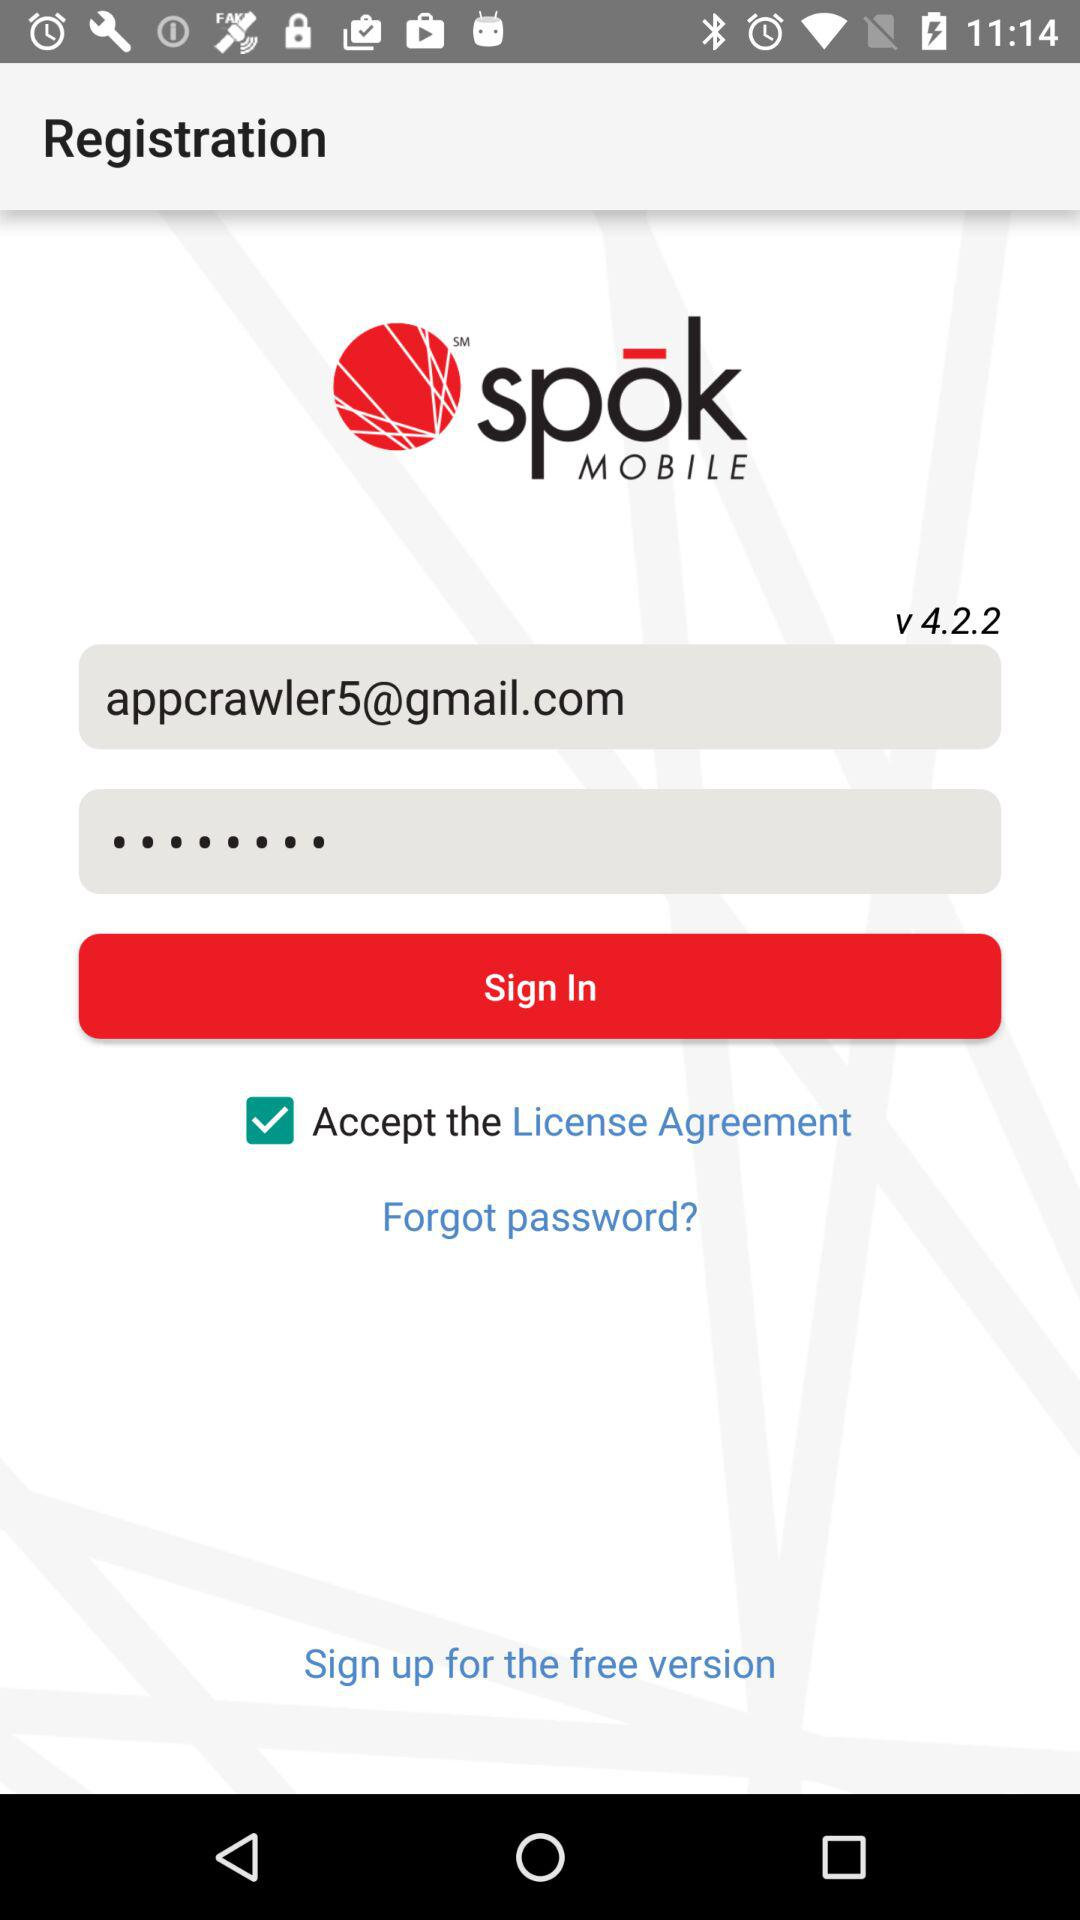What is the version of the application? The version of the application is v 4.2.2. 